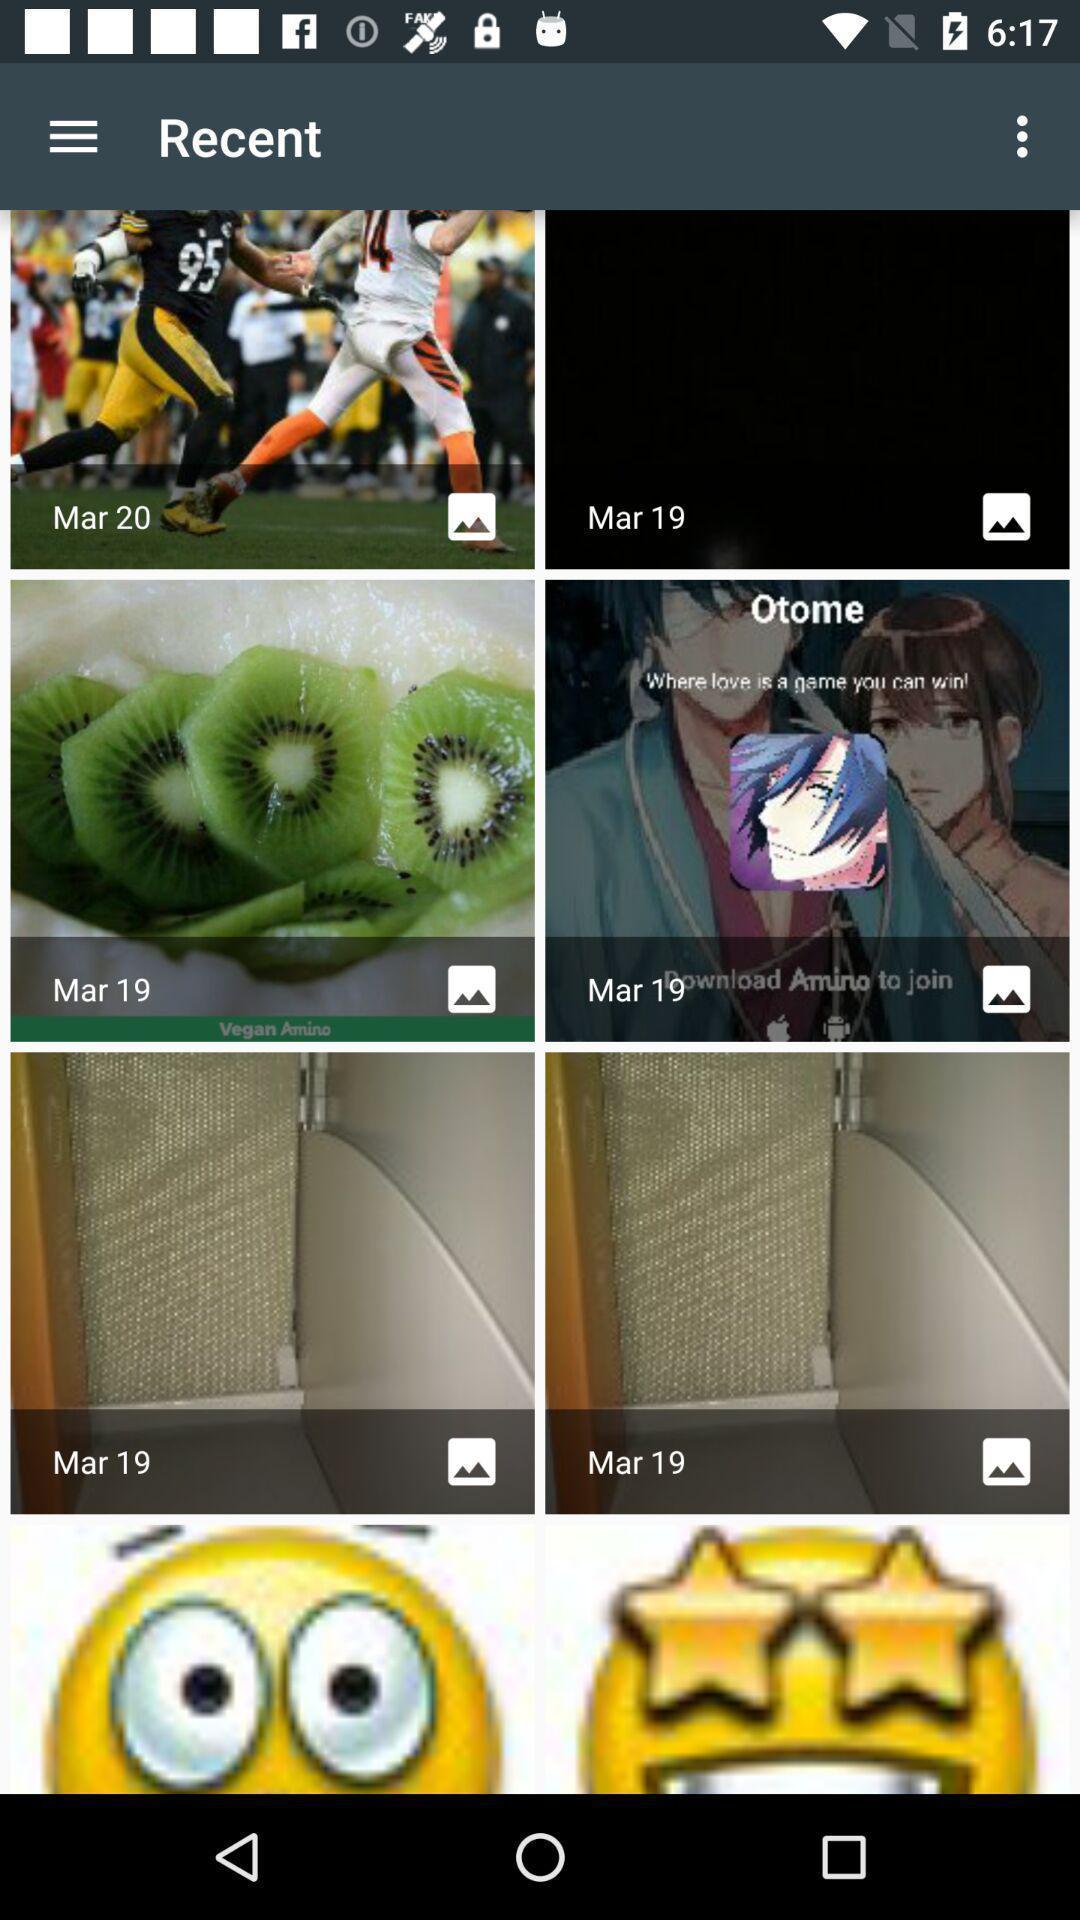Describe the visual elements of this screenshot. Screen displaying recent images. 